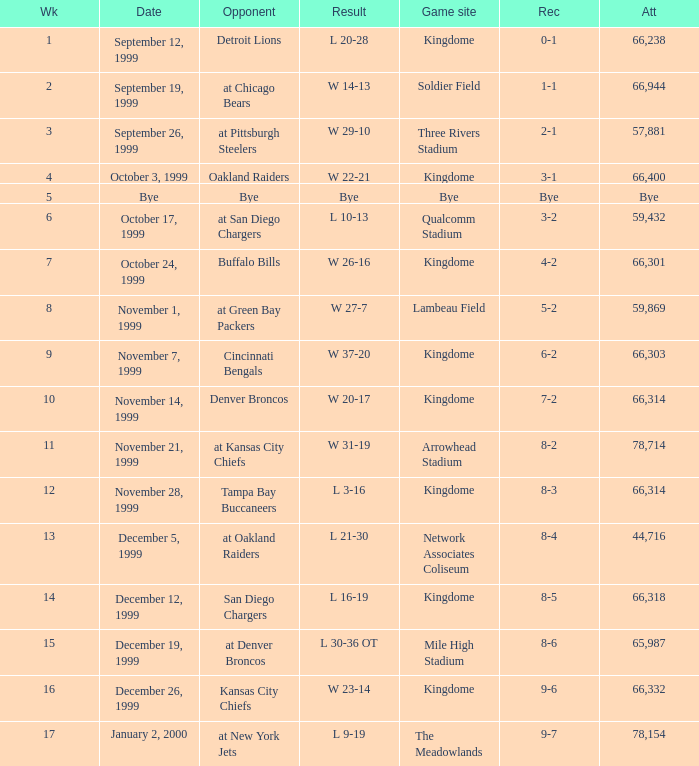What was the result of the game that was played on week 15? L 30-36 OT. 